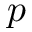<formula> <loc_0><loc_0><loc_500><loc_500>p</formula> 